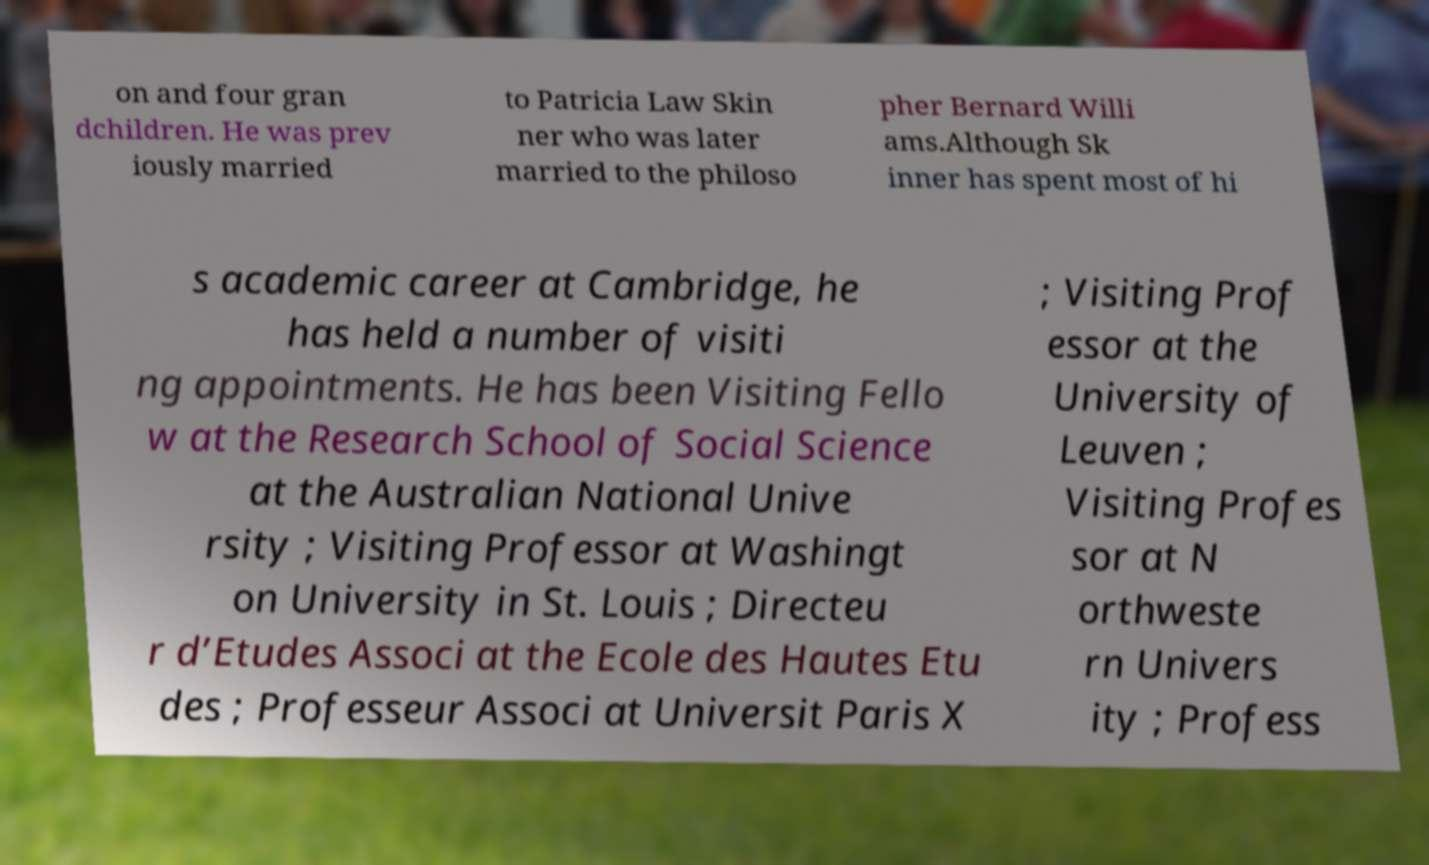What messages or text are displayed in this image? I need them in a readable, typed format. on and four gran dchildren. He was prev iously married to Patricia Law Skin ner who was later married to the philoso pher Bernard Willi ams.Although Sk inner has spent most of hi s academic career at Cambridge, he has held a number of visiti ng appointments. He has been Visiting Fello w at the Research School of Social Science at the Australian National Unive rsity ; Visiting Professor at Washingt on University in St. Louis ; Directeu r d’Etudes Associ at the Ecole des Hautes Etu des ; Professeur Associ at Universit Paris X ; Visiting Prof essor at the University of Leuven ; Visiting Profes sor at N orthweste rn Univers ity ; Profess 